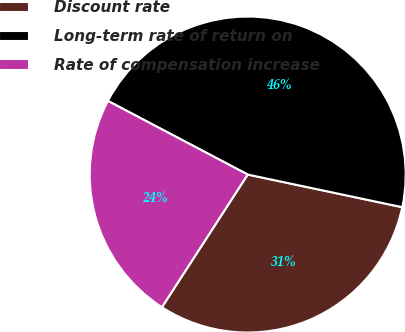<chart> <loc_0><loc_0><loc_500><loc_500><pie_chart><fcel>Discount rate<fcel>Long-term rate of return on<fcel>Rate of compensation increase<nl><fcel>30.82%<fcel>45.6%<fcel>23.58%<nl></chart> 